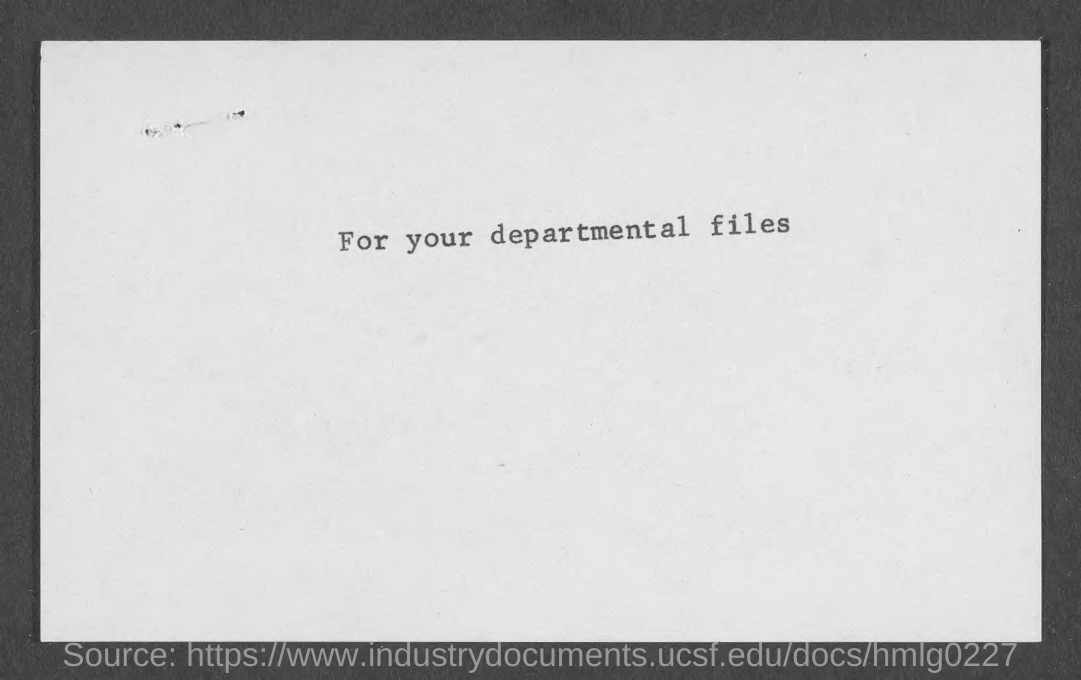Identify some key points in this picture. The text on the document is "For your departmental files. 